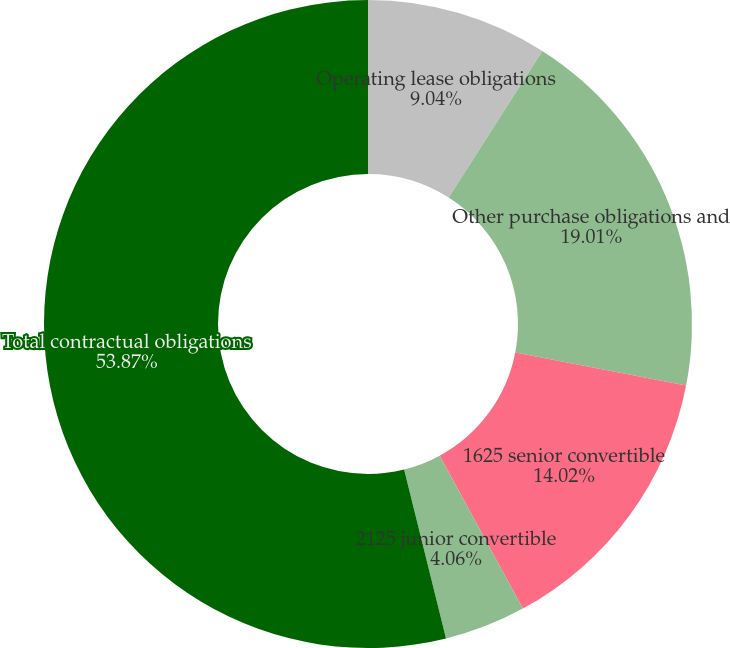Convert chart to OTSL. <chart><loc_0><loc_0><loc_500><loc_500><pie_chart><fcel>Operating lease obligations<fcel>Other purchase obligations and<fcel>1625 senior convertible<fcel>2125 junior convertible<fcel>Total contractual obligations<nl><fcel>9.04%<fcel>19.0%<fcel>14.02%<fcel>4.06%<fcel>53.86%<nl></chart> 